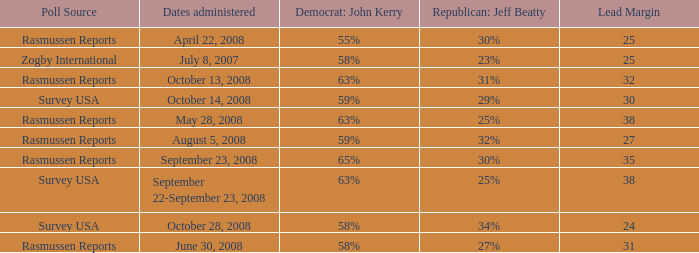Who is the poll source that has Republican: Jeff Beatty behind at 27%? Rasmussen Reports. 